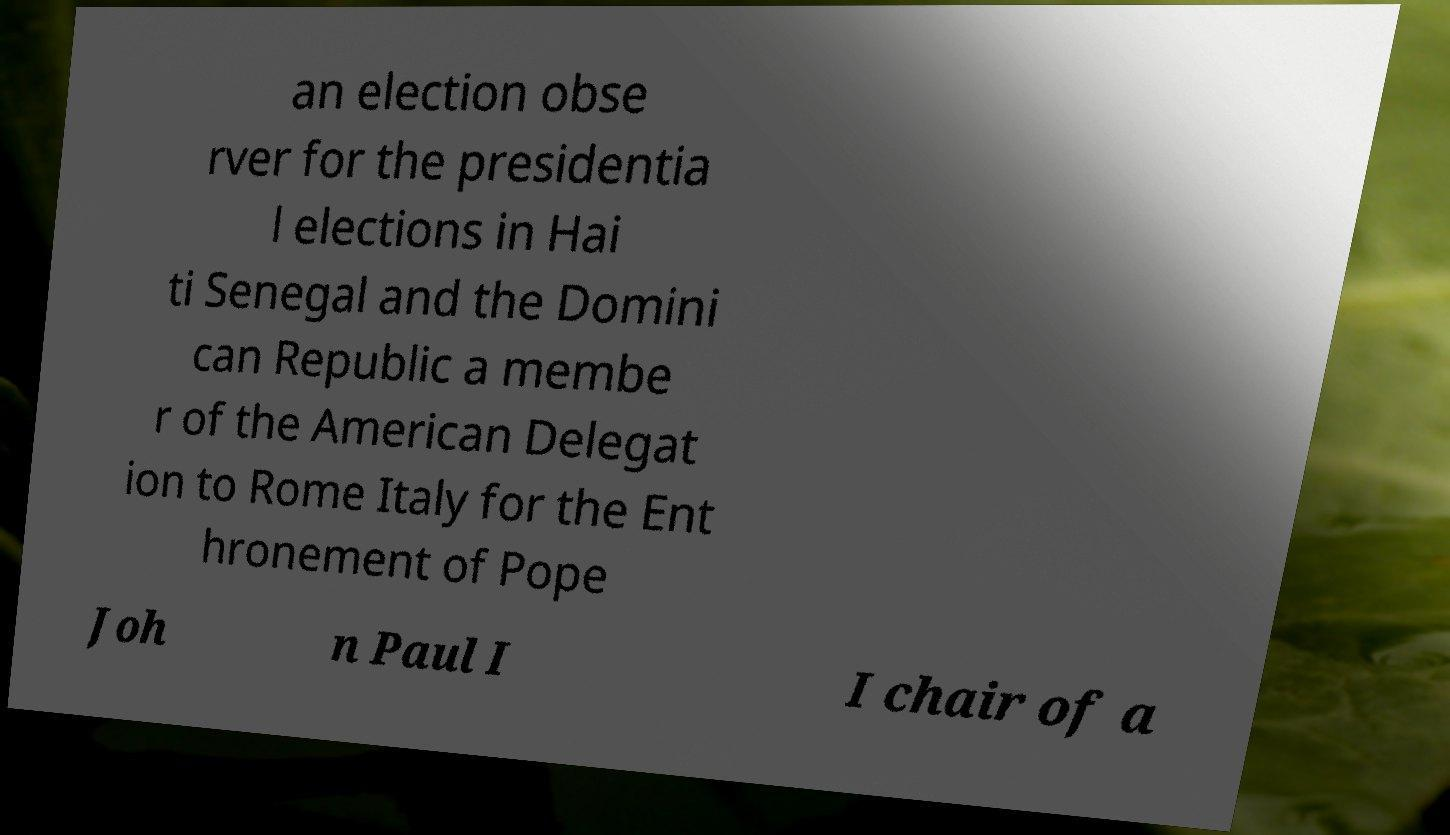Please identify and transcribe the text found in this image. an election obse rver for the presidentia l elections in Hai ti Senegal and the Domini can Republic a membe r of the American Delegat ion to Rome Italy for the Ent hronement of Pope Joh n Paul I I chair of a 